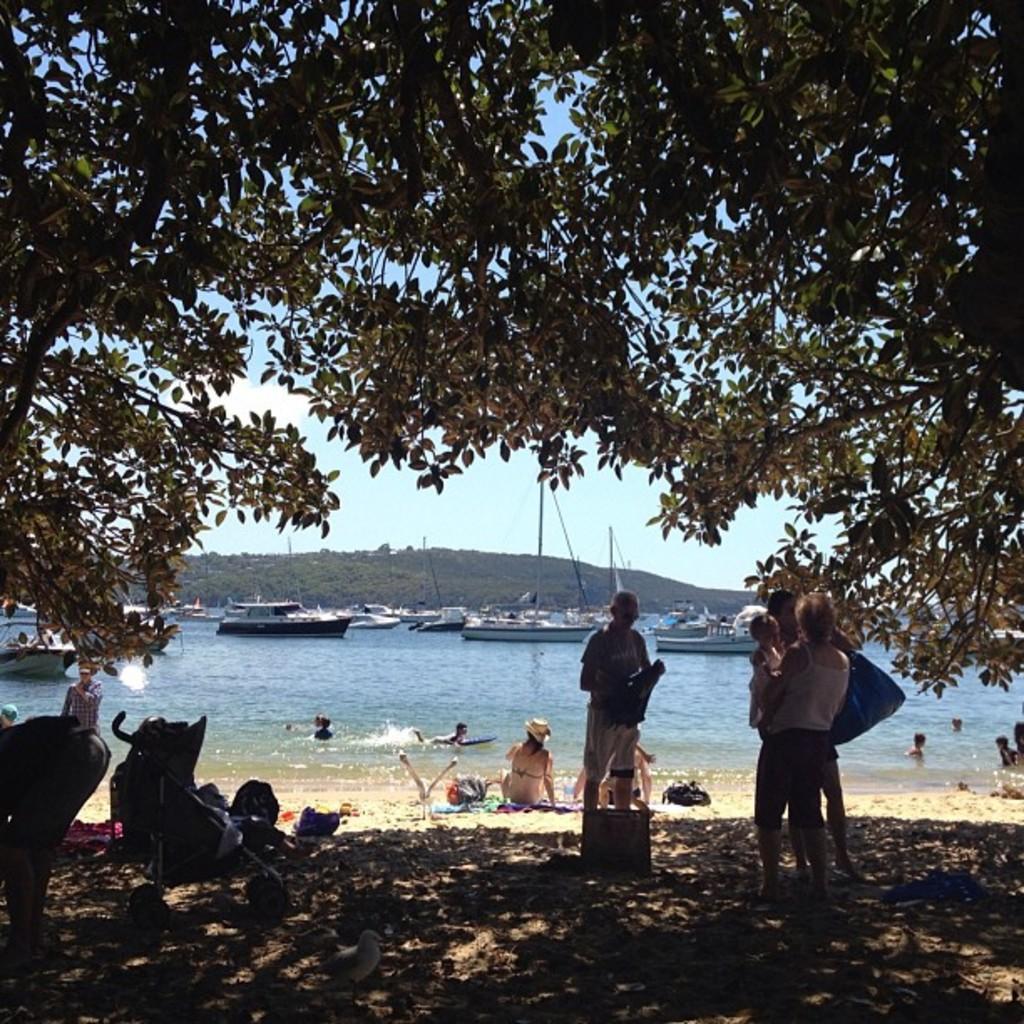Please provide a concise description of this image. In this image we can see a beach. On beach people are standing, sitting, walking and swimming. On the top of the image one tree is present. Background of the image we can see ship on water and some pillar. 